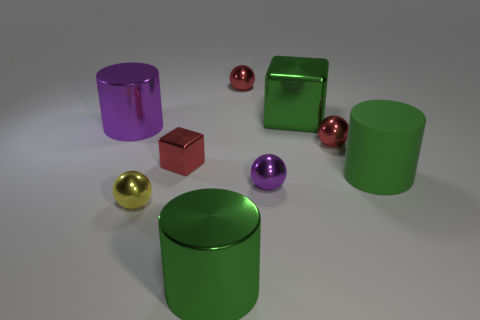What number of things are either shiny cylinders to the right of the purple cylinder or small red metallic spheres?
Your response must be concise. 3. What is the material of the other green cylinder that is the same size as the green metal cylinder?
Give a very brief answer. Rubber. There is a small metal ball behind the big metallic cylinder that is on the left side of the yellow shiny ball; what is its color?
Make the answer very short. Red. There is a green block; what number of small purple things are behind it?
Keep it short and to the point. 0. What is the color of the big rubber object?
Give a very brief answer. Green. What number of large things are either green matte things or shiny cylinders?
Ensure brevity in your answer.  3. There is a metal cube that is left of the purple sphere; does it have the same color as the small object that is right of the purple sphere?
Provide a short and direct response. Yes. How many other things are there of the same color as the big metal cube?
Offer a terse response. 2. What shape is the green thing behind the big green rubber object?
Your answer should be very brief. Cube. Is the number of small metallic balls less than the number of small metal things?
Provide a short and direct response. Yes. 